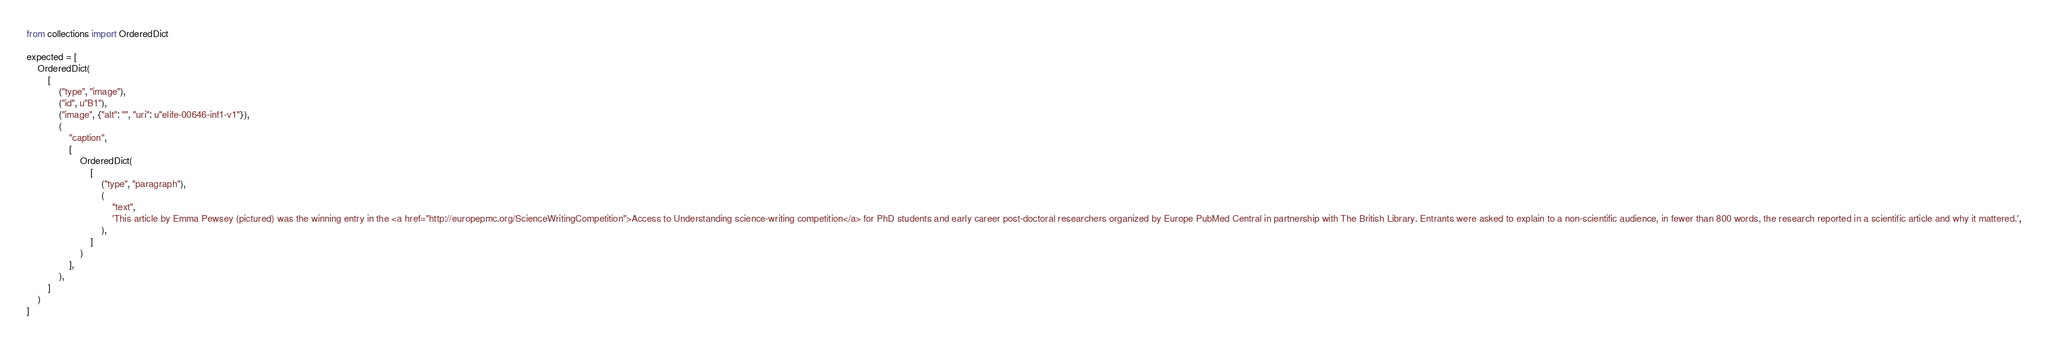<code> <loc_0><loc_0><loc_500><loc_500><_Python_>from collections import OrderedDict

expected = [
    OrderedDict(
        [
            ("type", "image"),
            ("id", u"B1"),
            ("image", {"alt": "", "uri": u"elife-00646-inf1-v1"}),
            (
                "caption",
                [
                    OrderedDict(
                        [
                            ("type", "paragraph"),
                            (
                                "text",
                                'This article by Emma Pewsey (pictured) was the winning entry in the <a href="http://europepmc.org/ScienceWritingCompetition">Access to Understanding science-writing competition</a> for PhD students and early career post-doctoral researchers organized by Europe PubMed Central in partnership with The British Library. Entrants were asked to explain to a non-scientific audience, in fewer than 800 words, the research reported in a scientific article and why it mattered.',
                            ),
                        ]
                    )
                ],
            ),
        ]
    )
]
</code> 